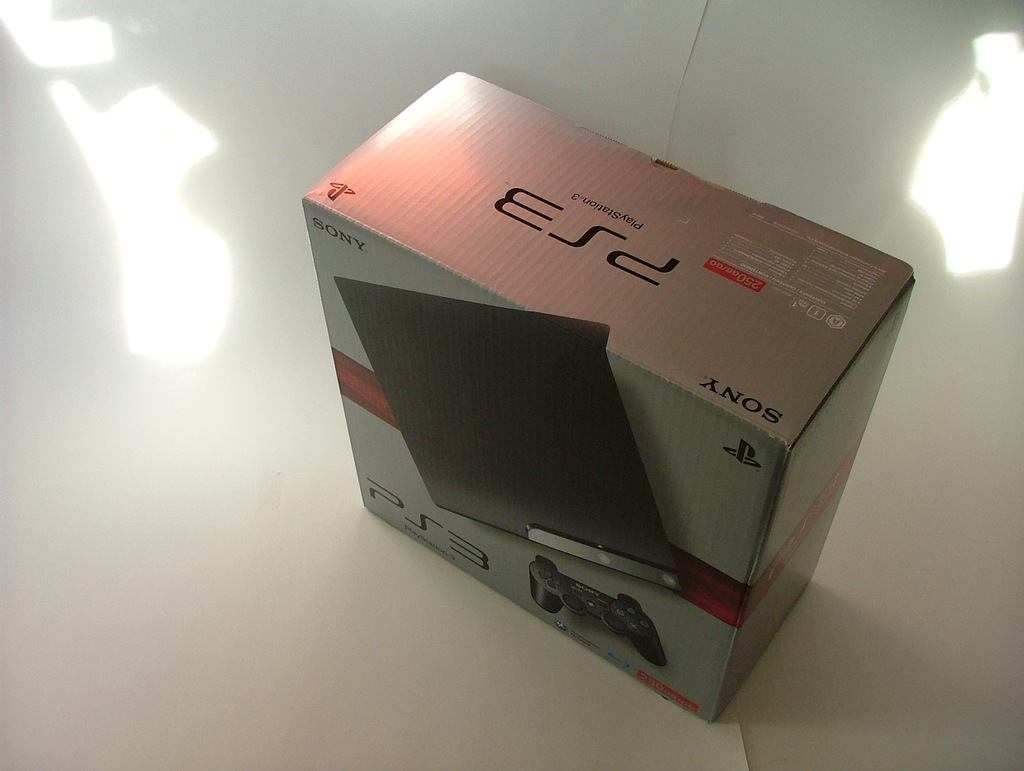What are the noticeable features on the PS3 box displayed in the image? The PS3 box features a large PlayStation 3 logo at the top, a graphic of the gaming console and its controller on the front, and the Sony logo prominently displayed. The box’s silver and red gradient design is eye-catching, and there are labels indicating it is a 160GB model and includes information about HDMI connectivity. 